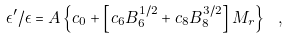<formula> <loc_0><loc_0><loc_500><loc_500>\epsilon ^ { \prime } / \epsilon = A \left \{ c _ { 0 } + \left [ c _ { 6 } B _ { 6 } ^ { 1 / 2 } + c _ { 8 } B _ { 8 } ^ { 3 / 2 } \right ] M _ { r } \right \} \ ,</formula> 